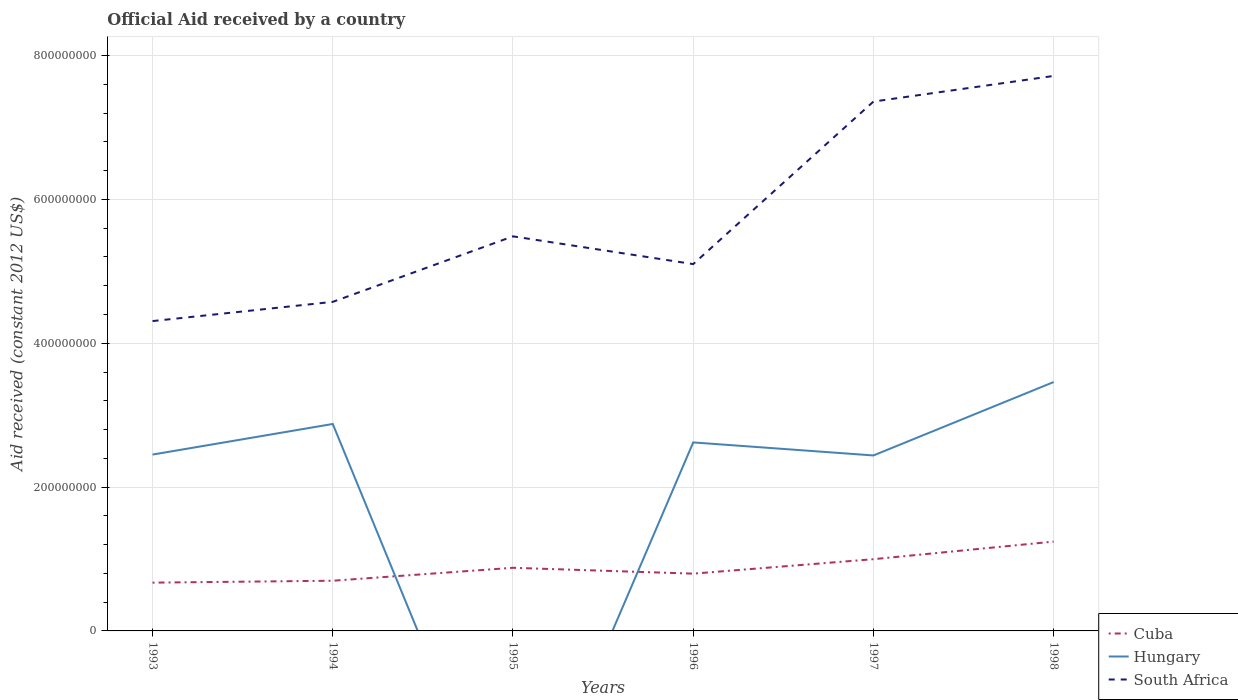Is the number of lines equal to the number of legend labels?
Offer a very short reply. No. What is the total net official aid received in Hungary in the graph?
Offer a very short reply. 4.38e+07. What is the difference between the highest and the second highest net official aid received in Cuba?
Your response must be concise. 5.71e+07. What is the difference between the highest and the lowest net official aid received in South Africa?
Keep it short and to the point. 2. Is the net official aid received in South Africa strictly greater than the net official aid received in Hungary over the years?
Give a very brief answer. No. Does the graph contain any zero values?
Your answer should be very brief. Yes. Does the graph contain grids?
Provide a succinct answer. Yes. Where does the legend appear in the graph?
Provide a short and direct response. Bottom right. How many legend labels are there?
Ensure brevity in your answer.  3. What is the title of the graph?
Keep it short and to the point. Official Aid received by a country. Does "South Asia" appear as one of the legend labels in the graph?
Your response must be concise. No. What is the label or title of the Y-axis?
Provide a short and direct response. Aid received (constant 2012 US$). What is the Aid received (constant 2012 US$) in Cuba in 1993?
Ensure brevity in your answer.  6.71e+07. What is the Aid received (constant 2012 US$) of Hungary in 1993?
Offer a terse response. 2.45e+08. What is the Aid received (constant 2012 US$) in South Africa in 1993?
Your answer should be very brief. 4.31e+08. What is the Aid received (constant 2012 US$) of Cuba in 1994?
Make the answer very short. 6.98e+07. What is the Aid received (constant 2012 US$) of Hungary in 1994?
Keep it short and to the point. 2.88e+08. What is the Aid received (constant 2012 US$) in South Africa in 1994?
Provide a succinct answer. 4.58e+08. What is the Aid received (constant 2012 US$) of Cuba in 1995?
Provide a short and direct response. 8.78e+07. What is the Aid received (constant 2012 US$) of Hungary in 1995?
Make the answer very short. 0. What is the Aid received (constant 2012 US$) in South Africa in 1995?
Offer a terse response. 5.49e+08. What is the Aid received (constant 2012 US$) of Cuba in 1996?
Make the answer very short. 7.96e+07. What is the Aid received (constant 2012 US$) of Hungary in 1996?
Ensure brevity in your answer.  2.62e+08. What is the Aid received (constant 2012 US$) in South Africa in 1996?
Offer a terse response. 5.10e+08. What is the Aid received (constant 2012 US$) in Cuba in 1997?
Keep it short and to the point. 9.98e+07. What is the Aid received (constant 2012 US$) of Hungary in 1997?
Make the answer very short. 2.44e+08. What is the Aid received (constant 2012 US$) in South Africa in 1997?
Your answer should be very brief. 7.36e+08. What is the Aid received (constant 2012 US$) in Cuba in 1998?
Your answer should be compact. 1.24e+08. What is the Aid received (constant 2012 US$) in Hungary in 1998?
Your answer should be very brief. 3.46e+08. What is the Aid received (constant 2012 US$) in South Africa in 1998?
Your response must be concise. 7.72e+08. Across all years, what is the maximum Aid received (constant 2012 US$) in Cuba?
Your response must be concise. 1.24e+08. Across all years, what is the maximum Aid received (constant 2012 US$) of Hungary?
Provide a succinct answer. 3.46e+08. Across all years, what is the maximum Aid received (constant 2012 US$) of South Africa?
Offer a terse response. 7.72e+08. Across all years, what is the minimum Aid received (constant 2012 US$) in Cuba?
Ensure brevity in your answer.  6.71e+07. Across all years, what is the minimum Aid received (constant 2012 US$) in Hungary?
Your answer should be very brief. 0. Across all years, what is the minimum Aid received (constant 2012 US$) in South Africa?
Provide a short and direct response. 4.31e+08. What is the total Aid received (constant 2012 US$) in Cuba in the graph?
Provide a succinct answer. 5.28e+08. What is the total Aid received (constant 2012 US$) of Hungary in the graph?
Your answer should be very brief. 1.39e+09. What is the total Aid received (constant 2012 US$) in South Africa in the graph?
Your answer should be compact. 3.45e+09. What is the difference between the Aid received (constant 2012 US$) in Cuba in 1993 and that in 1994?
Give a very brief answer. -2.66e+06. What is the difference between the Aid received (constant 2012 US$) of Hungary in 1993 and that in 1994?
Your response must be concise. -4.25e+07. What is the difference between the Aid received (constant 2012 US$) in South Africa in 1993 and that in 1994?
Give a very brief answer. -2.67e+07. What is the difference between the Aid received (constant 2012 US$) in Cuba in 1993 and that in 1995?
Your answer should be compact. -2.07e+07. What is the difference between the Aid received (constant 2012 US$) in South Africa in 1993 and that in 1995?
Offer a very short reply. -1.18e+08. What is the difference between the Aid received (constant 2012 US$) in Cuba in 1993 and that in 1996?
Keep it short and to the point. -1.25e+07. What is the difference between the Aid received (constant 2012 US$) in Hungary in 1993 and that in 1996?
Keep it short and to the point. -1.69e+07. What is the difference between the Aid received (constant 2012 US$) of South Africa in 1993 and that in 1996?
Ensure brevity in your answer.  -7.92e+07. What is the difference between the Aid received (constant 2012 US$) in Cuba in 1993 and that in 1997?
Your answer should be compact. -3.26e+07. What is the difference between the Aid received (constant 2012 US$) of Hungary in 1993 and that in 1997?
Offer a very short reply. 1.23e+06. What is the difference between the Aid received (constant 2012 US$) of South Africa in 1993 and that in 1997?
Your answer should be compact. -3.05e+08. What is the difference between the Aid received (constant 2012 US$) of Cuba in 1993 and that in 1998?
Keep it short and to the point. -5.71e+07. What is the difference between the Aid received (constant 2012 US$) of Hungary in 1993 and that in 1998?
Provide a succinct answer. -1.01e+08. What is the difference between the Aid received (constant 2012 US$) of South Africa in 1993 and that in 1998?
Offer a very short reply. -3.41e+08. What is the difference between the Aid received (constant 2012 US$) in Cuba in 1994 and that in 1995?
Offer a very short reply. -1.80e+07. What is the difference between the Aid received (constant 2012 US$) in South Africa in 1994 and that in 1995?
Offer a very short reply. -9.11e+07. What is the difference between the Aid received (constant 2012 US$) in Cuba in 1994 and that in 1996?
Provide a succinct answer. -9.85e+06. What is the difference between the Aid received (constant 2012 US$) of Hungary in 1994 and that in 1996?
Make the answer very short. 2.56e+07. What is the difference between the Aid received (constant 2012 US$) of South Africa in 1994 and that in 1996?
Ensure brevity in your answer.  -5.25e+07. What is the difference between the Aid received (constant 2012 US$) in Cuba in 1994 and that in 1997?
Offer a very short reply. -3.00e+07. What is the difference between the Aid received (constant 2012 US$) of Hungary in 1994 and that in 1997?
Provide a short and direct response. 4.38e+07. What is the difference between the Aid received (constant 2012 US$) of South Africa in 1994 and that in 1997?
Your response must be concise. -2.78e+08. What is the difference between the Aid received (constant 2012 US$) of Cuba in 1994 and that in 1998?
Offer a terse response. -5.44e+07. What is the difference between the Aid received (constant 2012 US$) in Hungary in 1994 and that in 1998?
Your response must be concise. -5.83e+07. What is the difference between the Aid received (constant 2012 US$) in South Africa in 1994 and that in 1998?
Give a very brief answer. -3.14e+08. What is the difference between the Aid received (constant 2012 US$) of Cuba in 1995 and that in 1996?
Make the answer very short. 8.15e+06. What is the difference between the Aid received (constant 2012 US$) in South Africa in 1995 and that in 1996?
Keep it short and to the point. 3.86e+07. What is the difference between the Aid received (constant 2012 US$) in Cuba in 1995 and that in 1997?
Keep it short and to the point. -1.20e+07. What is the difference between the Aid received (constant 2012 US$) of South Africa in 1995 and that in 1997?
Your response must be concise. -1.87e+08. What is the difference between the Aid received (constant 2012 US$) of Cuba in 1995 and that in 1998?
Give a very brief answer. -3.64e+07. What is the difference between the Aid received (constant 2012 US$) of South Africa in 1995 and that in 1998?
Your response must be concise. -2.23e+08. What is the difference between the Aid received (constant 2012 US$) of Cuba in 1996 and that in 1997?
Your answer should be very brief. -2.01e+07. What is the difference between the Aid received (constant 2012 US$) of Hungary in 1996 and that in 1997?
Offer a terse response. 1.81e+07. What is the difference between the Aid received (constant 2012 US$) of South Africa in 1996 and that in 1997?
Provide a short and direct response. -2.26e+08. What is the difference between the Aid received (constant 2012 US$) of Cuba in 1996 and that in 1998?
Provide a short and direct response. -4.46e+07. What is the difference between the Aid received (constant 2012 US$) in Hungary in 1996 and that in 1998?
Your answer should be compact. -8.40e+07. What is the difference between the Aid received (constant 2012 US$) of South Africa in 1996 and that in 1998?
Give a very brief answer. -2.62e+08. What is the difference between the Aid received (constant 2012 US$) in Cuba in 1997 and that in 1998?
Offer a terse response. -2.44e+07. What is the difference between the Aid received (constant 2012 US$) in Hungary in 1997 and that in 1998?
Provide a short and direct response. -1.02e+08. What is the difference between the Aid received (constant 2012 US$) of South Africa in 1997 and that in 1998?
Your response must be concise. -3.57e+07. What is the difference between the Aid received (constant 2012 US$) of Cuba in 1993 and the Aid received (constant 2012 US$) of Hungary in 1994?
Offer a very short reply. -2.21e+08. What is the difference between the Aid received (constant 2012 US$) in Cuba in 1993 and the Aid received (constant 2012 US$) in South Africa in 1994?
Ensure brevity in your answer.  -3.90e+08. What is the difference between the Aid received (constant 2012 US$) in Hungary in 1993 and the Aid received (constant 2012 US$) in South Africa in 1994?
Provide a short and direct response. -2.12e+08. What is the difference between the Aid received (constant 2012 US$) of Cuba in 1993 and the Aid received (constant 2012 US$) of South Africa in 1995?
Your answer should be compact. -4.82e+08. What is the difference between the Aid received (constant 2012 US$) in Hungary in 1993 and the Aid received (constant 2012 US$) in South Africa in 1995?
Offer a very short reply. -3.03e+08. What is the difference between the Aid received (constant 2012 US$) of Cuba in 1993 and the Aid received (constant 2012 US$) of Hungary in 1996?
Ensure brevity in your answer.  -1.95e+08. What is the difference between the Aid received (constant 2012 US$) in Cuba in 1993 and the Aid received (constant 2012 US$) in South Africa in 1996?
Your answer should be very brief. -4.43e+08. What is the difference between the Aid received (constant 2012 US$) of Hungary in 1993 and the Aid received (constant 2012 US$) of South Africa in 1996?
Give a very brief answer. -2.65e+08. What is the difference between the Aid received (constant 2012 US$) of Cuba in 1993 and the Aid received (constant 2012 US$) of Hungary in 1997?
Make the answer very short. -1.77e+08. What is the difference between the Aid received (constant 2012 US$) of Cuba in 1993 and the Aid received (constant 2012 US$) of South Africa in 1997?
Give a very brief answer. -6.69e+08. What is the difference between the Aid received (constant 2012 US$) of Hungary in 1993 and the Aid received (constant 2012 US$) of South Africa in 1997?
Your answer should be very brief. -4.91e+08. What is the difference between the Aid received (constant 2012 US$) in Cuba in 1993 and the Aid received (constant 2012 US$) in Hungary in 1998?
Your answer should be compact. -2.79e+08. What is the difference between the Aid received (constant 2012 US$) of Cuba in 1993 and the Aid received (constant 2012 US$) of South Africa in 1998?
Offer a terse response. -7.05e+08. What is the difference between the Aid received (constant 2012 US$) in Hungary in 1993 and the Aid received (constant 2012 US$) in South Africa in 1998?
Make the answer very short. -5.27e+08. What is the difference between the Aid received (constant 2012 US$) of Cuba in 1994 and the Aid received (constant 2012 US$) of South Africa in 1995?
Provide a short and direct response. -4.79e+08. What is the difference between the Aid received (constant 2012 US$) of Hungary in 1994 and the Aid received (constant 2012 US$) of South Africa in 1995?
Your answer should be compact. -2.61e+08. What is the difference between the Aid received (constant 2012 US$) of Cuba in 1994 and the Aid received (constant 2012 US$) of Hungary in 1996?
Offer a very short reply. -1.92e+08. What is the difference between the Aid received (constant 2012 US$) in Cuba in 1994 and the Aid received (constant 2012 US$) in South Africa in 1996?
Your answer should be very brief. -4.40e+08. What is the difference between the Aid received (constant 2012 US$) in Hungary in 1994 and the Aid received (constant 2012 US$) in South Africa in 1996?
Provide a succinct answer. -2.22e+08. What is the difference between the Aid received (constant 2012 US$) in Cuba in 1994 and the Aid received (constant 2012 US$) in Hungary in 1997?
Your response must be concise. -1.74e+08. What is the difference between the Aid received (constant 2012 US$) in Cuba in 1994 and the Aid received (constant 2012 US$) in South Africa in 1997?
Ensure brevity in your answer.  -6.66e+08. What is the difference between the Aid received (constant 2012 US$) in Hungary in 1994 and the Aid received (constant 2012 US$) in South Africa in 1997?
Offer a very short reply. -4.48e+08. What is the difference between the Aid received (constant 2012 US$) in Cuba in 1994 and the Aid received (constant 2012 US$) in Hungary in 1998?
Ensure brevity in your answer.  -2.76e+08. What is the difference between the Aid received (constant 2012 US$) of Cuba in 1994 and the Aid received (constant 2012 US$) of South Africa in 1998?
Your response must be concise. -7.02e+08. What is the difference between the Aid received (constant 2012 US$) of Hungary in 1994 and the Aid received (constant 2012 US$) of South Africa in 1998?
Offer a very short reply. -4.84e+08. What is the difference between the Aid received (constant 2012 US$) of Cuba in 1995 and the Aid received (constant 2012 US$) of Hungary in 1996?
Your answer should be compact. -1.74e+08. What is the difference between the Aid received (constant 2012 US$) in Cuba in 1995 and the Aid received (constant 2012 US$) in South Africa in 1996?
Make the answer very short. -4.22e+08. What is the difference between the Aid received (constant 2012 US$) in Cuba in 1995 and the Aid received (constant 2012 US$) in Hungary in 1997?
Keep it short and to the point. -1.56e+08. What is the difference between the Aid received (constant 2012 US$) of Cuba in 1995 and the Aid received (constant 2012 US$) of South Africa in 1997?
Your response must be concise. -6.48e+08. What is the difference between the Aid received (constant 2012 US$) of Cuba in 1995 and the Aid received (constant 2012 US$) of Hungary in 1998?
Keep it short and to the point. -2.58e+08. What is the difference between the Aid received (constant 2012 US$) in Cuba in 1995 and the Aid received (constant 2012 US$) in South Africa in 1998?
Ensure brevity in your answer.  -6.84e+08. What is the difference between the Aid received (constant 2012 US$) in Cuba in 1996 and the Aid received (constant 2012 US$) in Hungary in 1997?
Give a very brief answer. -1.64e+08. What is the difference between the Aid received (constant 2012 US$) of Cuba in 1996 and the Aid received (constant 2012 US$) of South Africa in 1997?
Your answer should be very brief. -6.56e+08. What is the difference between the Aid received (constant 2012 US$) of Hungary in 1996 and the Aid received (constant 2012 US$) of South Africa in 1997?
Offer a very short reply. -4.74e+08. What is the difference between the Aid received (constant 2012 US$) in Cuba in 1996 and the Aid received (constant 2012 US$) in Hungary in 1998?
Give a very brief answer. -2.66e+08. What is the difference between the Aid received (constant 2012 US$) of Cuba in 1996 and the Aid received (constant 2012 US$) of South Africa in 1998?
Make the answer very short. -6.92e+08. What is the difference between the Aid received (constant 2012 US$) of Hungary in 1996 and the Aid received (constant 2012 US$) of South Africa in 1998?
Your answer should be compact. -5.10e+08. What is the difference between the Aid received (constant 2012 US$) in Cuba in 1997 and the Aid received (constant 2012 US$) in Hungary in 1998?
Give a very brief answer. -2.46e+08. What is the difference between the Aid received (constant 2012 US$) of Cuba in 1997 and the Aid received (constant 2012 US$) of South Africa in 1998?
Your answer should be very brief. -6.72e+08. What is the difference between the Aid received (constant 2012 US$) of Hungary in 1997 and the Aid received (constant 2012 US$) of South Africa in 1998?
Make the answer very short. -5.28e+08. What is the average Aid received (constant 2012 US$) in Cuba per year?
Offer a terse response. 8.81e+07. What is the average Aid received (constant 2012 US$) in Hungary per year?
Provide a succinct answer. 2.31e+08. What is the average Aid received (constant 2012 US$) of South Africa per year?
Your answer should be very brief. 5.76e+08. In the year 1993, what is the difference between the Aid received (constant 2012 US$) in Cuba and Aid received (constant 2012 US$) in Hungary?
Your answer should be compact. -1.78e+08. In the year 1993, what is the difference between the Aid received (constant 2012 US$) in Cuba and Aid received (constant 2012 US$) in South Africa?
Offer a very short reply. -3.64e+08. In the year 1993, what is the difference between the Aid received (constant 2012 US$) in Hungary and Aid received (constant 2012 US$) in South Africa?
Provide a succinct answer. -1.86e+08. In the year 1994, what is the difference between the Aid received (constant 2012 US$) in Cuba and Aid received (constant 2012 US$) in Hungary?
Give a very brief answer. -2.18e+08. In the year 1994, what is the difference between the Aid received (constant 2012 US$) of Cuba and Aid received (constant 2012 US$) of South Africa?
Your answer should be very brief. -3.88e+08. In the year 1994, what is the difference between the Aid received (constant 2012 US$) of Hungary and Aid received (constant 2012 US$) of South Africa?
Provide a succinct answer. -1.70e+08. In the year 1995, what is the difference between the Aid received (constant 2012 US$) in Cuba and Aid received (constant 2012 US$) in South Africa?
Keep it short and to the point. -4.61e+08. In the year 1996, what is the difference between the Aid received (constant 2012 US$) in Cuba and Aid received (constant 2012 US$) in Hungary?
Your response must be concise. -1.82e+08. In the year 1996, what is the difference between the Aid received (constant 2012 US$) in Cuba and Aid received (constant 2012 US$) in South Africa?
Make the answer very short. -4.30e+08. In the year 1996, what is the difference between the Aid received (constant 2012 US$) in Hungary and Aid received (constant 2012 US$) in South Africa?
Make the answer very short. -2.48e+08. In the year 1997, what is the difference between the Aid received (constant 2012 US$) of Cuba and Aid received (constant 2012 US$) of Hungary?
Your answer should be compact. -1.44e+08. In the year 1997, what is the difference between the Aid received (constant 2012 US$) of Cuba and Aid received (constant 2012 US$) of South Africa?
Your answer should be compact. -6.36e+08. In the year 1997, what is the difference between the Aid received (constant 2012 US$) of Hungary and Aid received (constant 2012 US$) of South Africa?
Your answer should be very brief. -4.92e+08. In the year 1998, what is the difference between the Aid received (constant 2012 US$) in Cuba and Aid received (constant 2012 US$) in Hungary?
Keep it short and to the point. -2.22e+08. In the year 1998, what is the difference between the Aid received (constant 2012 US$) in Cuba and Aid received (constant 2012 US$) in South Africa?
Your response must be concise. -6.48e+08. In the year 1998, what is the difference between the Aid received (constant 2012 US$) of Hungary and Aid received (constant 2012 US$) of South Africa?
Your response must be concise. -4.26e+08. What is the ratio of the Aid received (constant 2012 US$) in Cuba in 1993 to that in 1994?
Offer a terse response. 0.96. What is the ratio of the Aid received (constant 2012 US$) of Hungary in 1993 to that in 1994?
Make the answer very short. 0.85. What is the ratio of the Aid received (constant 2012 US$) of South Africa in 1993 to that in 1994?
Offer a very short reply. 0.94. What is the ratio of the Aid received (constant 2012 US$) of Cuba in 1993 to that in 1995?
Your answer should be compact. 0.76. What is the ratio of the Aid received (constant 2012 US$) in South Africa in 1993 to that in 1995?
Ensure brevity in your answer.  0.79. What is the ratio of the Aid received (constant 2012 US$) in Cuba in 1993 to that in 1996?
Your answer should be compact. 0.84. What is the ratio of the Aid received (constant 2012 US$) of Hungary in 1993 to that in 1996?
Provide a succinct answer. 0.94. What is the ratio of the Aid received (constant 2012 US$) of South Africa in 1993 to that in 1996?
Your response must be concise. 0.84. What is the ratio of the Aid received (constant 2012 US$) of Cuba in 1993 to that in 1997?
Give a very brief answer. 0.67. What is the ratio of the Aid received (constant 2012 US$) in Hungary in 1993 to that in 1997?
Your response must be concise. 1. What is the ratio of the Aid received (constant 2012 US$) of South Africa in 1993 to that in 1997?
Give a very brief answer. 0.59. What is the ratio of the Aid received (constant 2012 US$) in Cuba in 1993 to that in 1998?
Give a very brief answer. 0.54. What is the ratio of the Aid received (constant 2012 US$) of Hungary in 1993 to that in 1998?
Ensure brevity in your answer.  0.71. What is the ratio of the Aid received (constant 2012 US$) of South Africa in 1993 to that in 1998?
Make the answer very short. 0.56. What is the ratio of the Aid received (constant 2012 US$) in Cuba in 1994 to that in 1995?
Provide a short and direct response. 0.8. What is the ratio of the Aid received (constant 2012 US$) in South Africa in 1994 to that in 1995?
Your answer should be compact. 0.83. What is the ratio of the Aid received (constant 2012 US$) in Cuba in 1994 to that in 1996?
Offer a very short reply. 0.88. What is the ratio of the Aid received (constant 2012 US$) in Hungary in 1994 to that in 1996?
Offer a very short reply. 1.1. What is the ratio of the Aid received (constant 2012 US$) in South Africa in 1994 to that in 1996?
Provide a succinct answer. 0.9. What is the ratio of the Aid received (constant 2012 US$) in Cuba in 1994 to that in 1997?
Your answer should be compact. 0.7. What is the ratio of the Aid received (constant 2012 US$) in Hungary in 1994 to that in 1997?
Your response must be concise. 1.18. What is the ratio of the Aid received (constant 2012 US$) of South Africa in 1994 to that in 1997?
Ensure brevity in your answer.  0.62. What is the ratio of the Aid received (constant 2012 US$) in Cuba in 1994 to that in 1998?
Make the answer very short. 0.56. What is the ratio of the Aid received (constant 2012 US$) in Hungary in 1994 to that in 1998?
Provide a short and direct response. 0.83. What is the ratio of the Aid received (constant 2012 US$) of South Africa in 1994 to that in 1998?
Ensure brevity in your answer.  0.59. What is the ratio of the Aid received (constant 2012 US$) in Cuba in 1995 to that in 1996?
Keep it short and to the point. 1.1. What is the ratio of the Aid received (constant 2012 US$) in South Africa in 1995 to that in 1996?
Ensure brevity in your answer.  1.08. What is the ratio of the Aid received (constant 2012 US$) of South Africa in 1995 to that in 1997?
Keep it short and to the point. 0.75. What is the ratio of the Aid received (constant 2012 US$) in Cuba in 1995 to that in 1998?
Offer a terse response. 0.71. What is the ratio of the Aid received (constant 2012 US$) of South Africa in 1995 to that in 1998?
Offer a very short reply. 0.71. What is the ratio of the Aid received (constant 2012 US$) of Cuba in 1996 to that in 1997?
Make the answer very short. 0.8. What is the ratio of the Aid received (constant 2012 US$) in Hungary in 1996 to that in 1997?
Your answer should be very brief. 1.07. What is the ratio of the Aid received (constant 2012 US$) in South Africa in 1996 to that in 1997?
Your answer should be compact. 0.69. What is the ratio of the Aid received (constant 2012 US$) of Cuba in 1996 to that in 1998?
Your response must be concise. 0.64. What is the ratio of the Aid received (constant 2012 US$) of Hungary in 1996 to that in 1998?
Your response must be concise. 0.76. What is the ratio of the Aid received (constant 2012 US$) in South Africa in 1996 to that in 1998?
Offer a terse response. 0.66. What is the ratio of the Aid received (constant 2012 US$) of Cuba in 1997 to that in 1998?
Provide a short and direct response. 0.8. What is the ratio of the Aid received (constant 2012 US$) in Hungary in 1997 to that in 1998?
Offer a very short reply. 0.7. What is the ratio of the Aid received (constant 2012 US$) of South Africa in 1997 to that in 1998?
Ensure brevity in your answer.  0.95. What is the difference between the highest and the second highest Aid received (constant 2012 US$) of Cuba?
Offer a terse response. 2.44e+07. What is the difference between the highest and the second highest Aid received (constant 2012 US$) in Hungary?
Your answer should be compact. 5.83e+07. What is the difference between the highest and the second highest Aid received (constant 2012 US$) of South Africa?
Your answer should be very brief. 3.57e+07. What is the difference between the highest and the lowest Aid received (constant 2012 US$) of Cuba?
Offer a very short reply. 5.71e+07. What is the difference between the highest and the lowest Aid received (constant 2012 US$) in Hungary?
Provide a short and direct response. 3.46e+08. What is the difference between the highest and the lowest Aid received (constant 2012 US$) of South Africa?
Offer a terse response. 3.41e+08. 